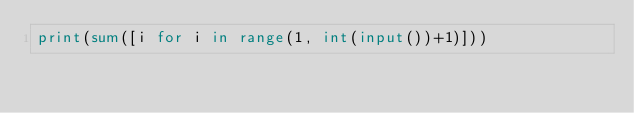<code> <loc_0><loc_0><loc_500><loc_500><_Python_>print(sum([i for i in range(1, int(input())+1)]))
</code> 